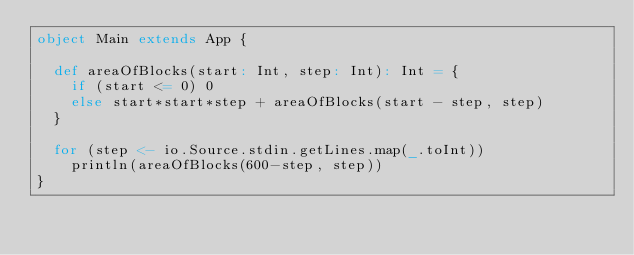Convert code to text. <code><loc_0><loc_0><loc_500><loc_500><_Scala_>object Main extends App {

  def areaOfBlocks(start: Int, step: Int): Int = {
    if (start <= 0) 0
    else start*start*step + areaOfBlocks(start - step, step)
  }

  for (step <- io.Source.stdin.getLines.map(_.toInt))
    println(areaOfBlocks(600-step, step))
}</code> 